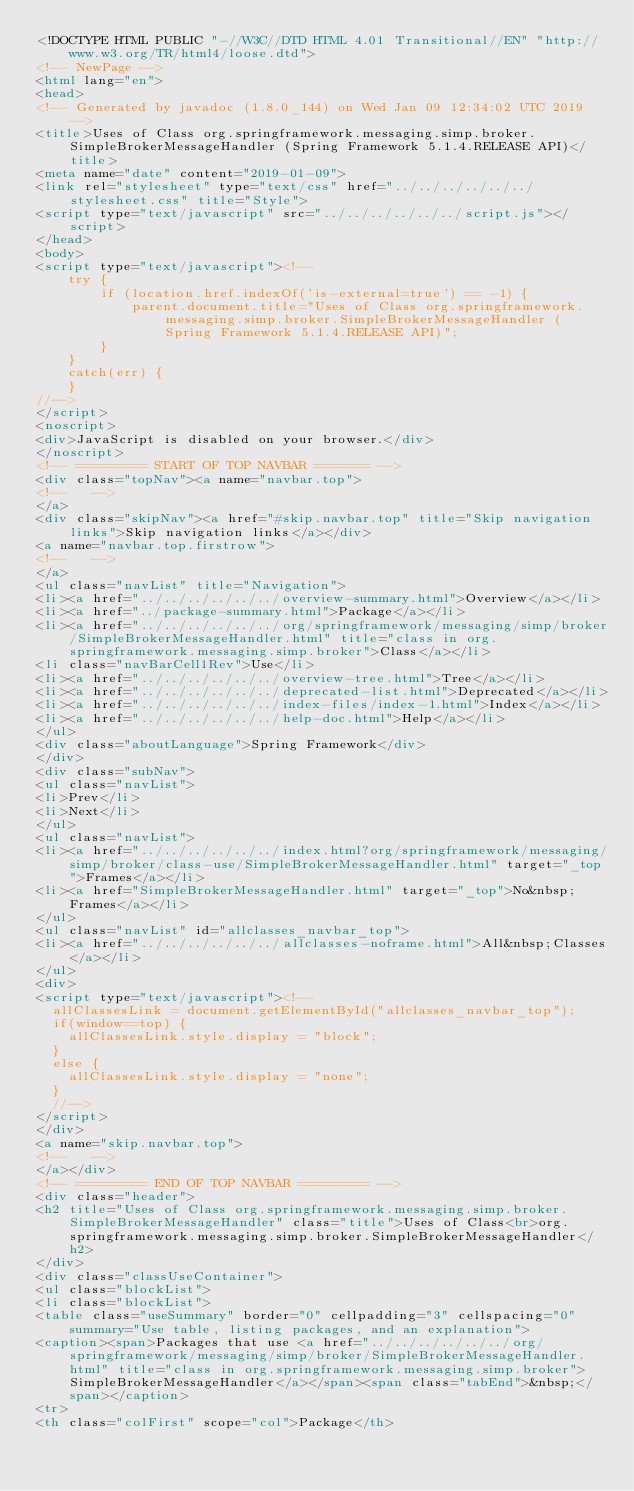<code> <loc_0><loc_0><loc_500><loc_500><_HTML_><!DOCTYPE HTML PUBLIC "-//W3C//DTD HTML 4.01 Transitional//EN" "http://www.w3.org/TR/html4/loose.dtd">
<!-- NewPage -->
<html lang="en">
<head>
<!-- Generated by javadoc (1.8.0_144) on Wed Jan 09 12:34:02 UTC 2019 -->
<title>Uses of Class org.springframework.messaging.simp.broker.SimpleBrokerMessageHandler (Spring Framework 5.1.4.RELEASE API)</title>
<meta name="date" content="2019-01-09">
<link rel="stylesheet" type="text/css" href="../../../../../../stylesheet.css" title="Style">
<script type="text/javascript" src="../../../../../../script.js"></script>
</head>
<body>
<script type="text/javascript"><!--
    try {
        if (location.href.indexOf('is-external=true') == -1) {
            parent.document.title="Uses of Class org.springframework.messaging.simp.broker.SimpleBrokerMessageHandler (Spring Framework 5.1.4.RELEASE API)";
        }
    }
    catch(err) {
    }
//-->
</script>
<noscript>
<div>JavaScript is disabled on your browser.</div>
</noscript>
<!-- ========= START OF TOP NAVBAR ======= -->
<div class="topNav"><a name="navbar.top">
<!--   -->
</a>
<div class="skipNav"><a href="#skip.navbar.top" title="Skip navigation links">Skip navigation links</a></div>
<a name="navbar.top.firstrow">
<!--   -->
</a>
<ul class="navList" title="Navigation">
<li><a href="../../../../../../overview-summary.html">Overview</a></li>
<li><a href="../package-summary.html">Package</a></li>
<li><a href="../../../../../../org/springframework/messaging/simp/broker/SimpleBrokerMessageHandler.html" title="class in org.springframework.messaging.simp.broker">Class</a></li>
<li class="navBarCell1Rev">Use</li>
<li><a href="../../../../../../overview-tree.html">Tree</a></li>
<li><a href="../../../../../../deprecated-list.html">Deprecated</a></li>
<li><a href="../../../../../../index-files/index-1.html">Index</a></li>
<li><a href="../../../../../../help-doc.html">Help</a></li>
</ul>
<div class="aboutLanguage">Spring Framework</div>
</div>
<div class="subNav">
<ul class="navList">
<li>Prev</li>
<li>Next</li>
</ul>
<ul class="navList">
<li><a href="../../../../../../index.html?org/springframework/messaging/simp/broker/class-use/SimpleBrokerMessageHandler.html" target="_top">Frames</a></li>
<li><a href="SimpleBrokerMessageHandler.html" target="_top">No&nbsp;Frames</a></li>
</ul>
<ul class="navList" id="allclasses_navbar_top">
<li><a href="../../../../../../allclasses-noframe.html">All&nbsp;Classes</a></li>
</ul>
<div>
<script type="text/javascript"><!--
  allClassesLink = document.getElementById("allclasses_navbar_top");
  if(window==top) {
    allClassesLink.style.display = "block";
  }
  else {
    allClassesLink.style.display = "none";
  }
  //-->
</script>
</div>
<a name="skip.navbar.top">
<!--   -->
</a></div>
<!-- ========= END OF TOP NAVBAR ========= -->
<div class="header">
<h2 title="Uses of Class org.springframework.messaging.simp.broker.SimpleBrokerMessageHandler" class="title">Uses of Class<br>org.springframework.messaging.simp.broker.SimpleBrokerMessageHandler</h2>
</div>
<div class="classUseContainer">
<ul class="blockList">
<li class="blockList">
<table class="useSummary" border="0" cellpadding="3" cellspacing="0" summary="Use table, listing packages, and an explanation">
<caption><span>Packages that use <a href="../../../../../../org/springframework/messaging/simp/broker/SimpleBrokerMessageHandler.html" title="class in org.springframework.messaging.simp.broker">SimpleBrokerMessageHandler</a></span><span class="tabEnd">&nbsp;</span></caption>
<tr>
<th class="colFirst" scope="col">Package</th></code> 